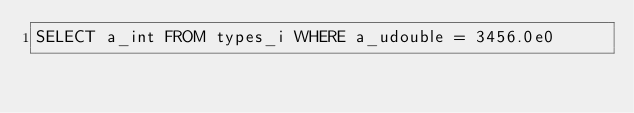<code> <loc_0><loc_0><loc_500><loc_500><_SQL_>SELECT a_int FROM types_i WHERE a_udouble = 3456.0e0
</code> 